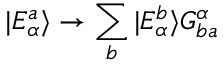Convert formula to latex. <formula><loc_0><loc_0><loc_500><loc_500>| E _ { \alpha } ^ { a } \rangle \rightarrow \sum _ { b } | E _ { \alpha } ^ { b } \rangle G _ { b a } ^ { \alpha }</formula> 